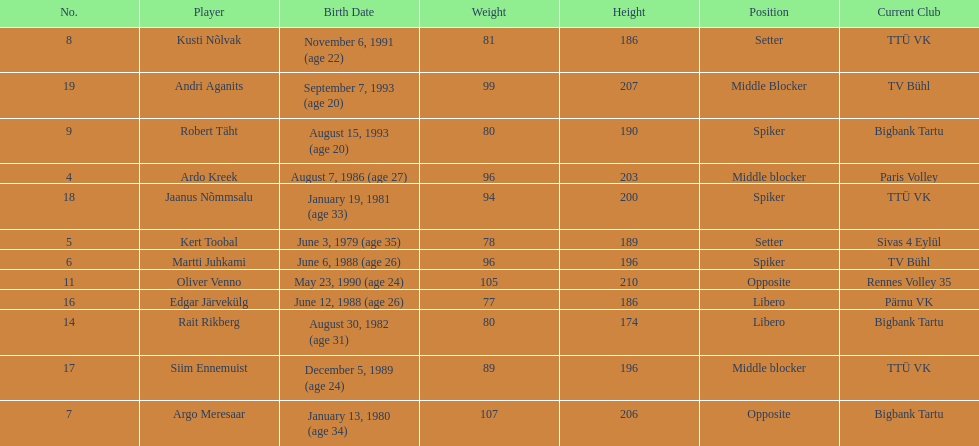How much taller in oliver venno than rait rikberg? 36. 